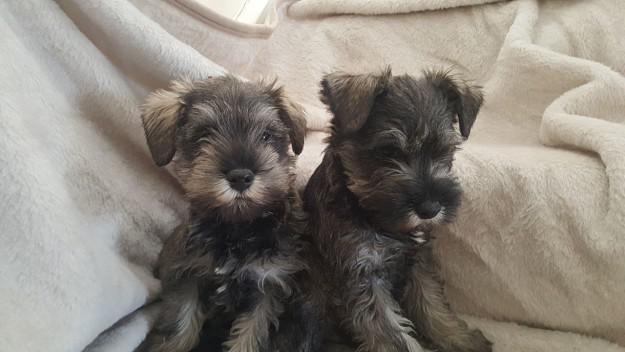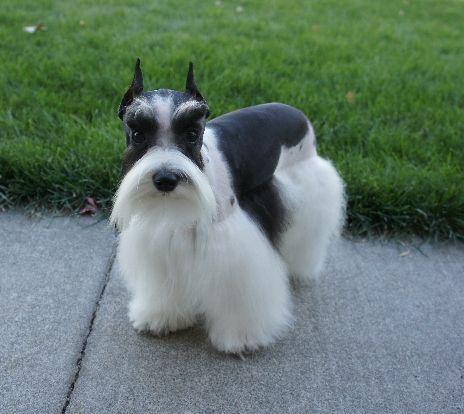The first image is the image on the left, the second image is the image on the right. Given the left and right images, does the statement "An image shows two schnauzers of similar size and coloring posed side-by-side." hold true? Answer yes or no. Yes. The first image is the image on the left, the second image is the image on the right. Considering the images on both sides, is "At least one dog is showing its tongue." valid? Answer yes or no. No. 